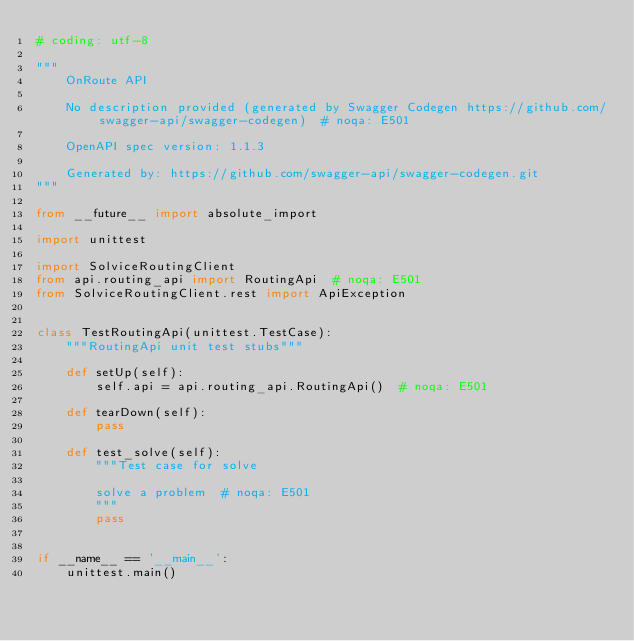Convert code to text. <code><loc_0><loc_0><loc_500><loc_500><_Python_># coding: utf-8

"""
    OnRoute API

    No description provided (generated by Swagger Codegen https://github.com/swagger-api/swagger-codegen)  # noqa: E501

    OpenAPI spec version: 1.1.3
    
    Generated by: https://github.com/swagger-api/swagger-codegen.git
"""

from __future__ import absolute_import

import unittest

import SolviceRoutingClient
from api.routing_api import RoutingApi  # noqa: E501
from SolviceRoutingClient.rest import ApiException


class TestRoutingApi(unittest.TestCase):
    """RoutingApi unit test stubs"""

    def setUp(self):
        self.api = api.routing_api.RoutingApi()  # noqa: E501

    def tearDown(self):
        pass

    def test_solve(self):
        """Test case for solve

        solve a problem  # noqa: E501
        """
        pass


if __name__ == '__main__':
    unittest.main()
</code> 